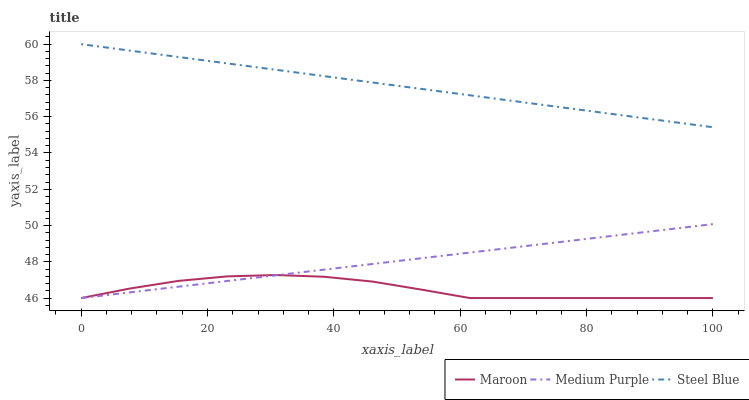Does Maroon have the minimum area under the curve?
Answer yes or no. Yes. Does Steel Blue have the maximum area under the curve?
Answer yes or no. Yes. Does Steel Blue have the minimum area under the curve?
Answer yes or no. No. Does Maroon have the maximum area under the curve?
Answer yes or no. No. Is Medium Purple the smoothest?
Answer yes or no. Yes. Is Maroon the roughest?
Answer yes or no. Yes. Is Steel Blue the smoothest?
Answer yes or no. No. Is Steel Blue the roughest?
Answer yes or no. No. Does Medium Purple have the lowest value?
Answer yes or no. Yes. Does Steel Blue have the lowest value?
Answer yes or no. No. Does Steel Blue have the highest value?
Answer yes or no. Yes. Does Maroon have the highest value?
Answer yes or no. No. Is Medium Purple less than Steel Blue?
Answer yes or no. Yes. Is Steel Blue greater than Medium Purple?
Answer yes or no. Yes. Does Medium Purple intersect Maroon?
Answer yes or no. Yes. Is Medium Purple less than Maroon?
Answer yes or no. No. Is Medium Purple greater than Maroon?
Answer yes or no. No. Does Medium Purple intersect Steel Blue?
Answer yes or no. No. 